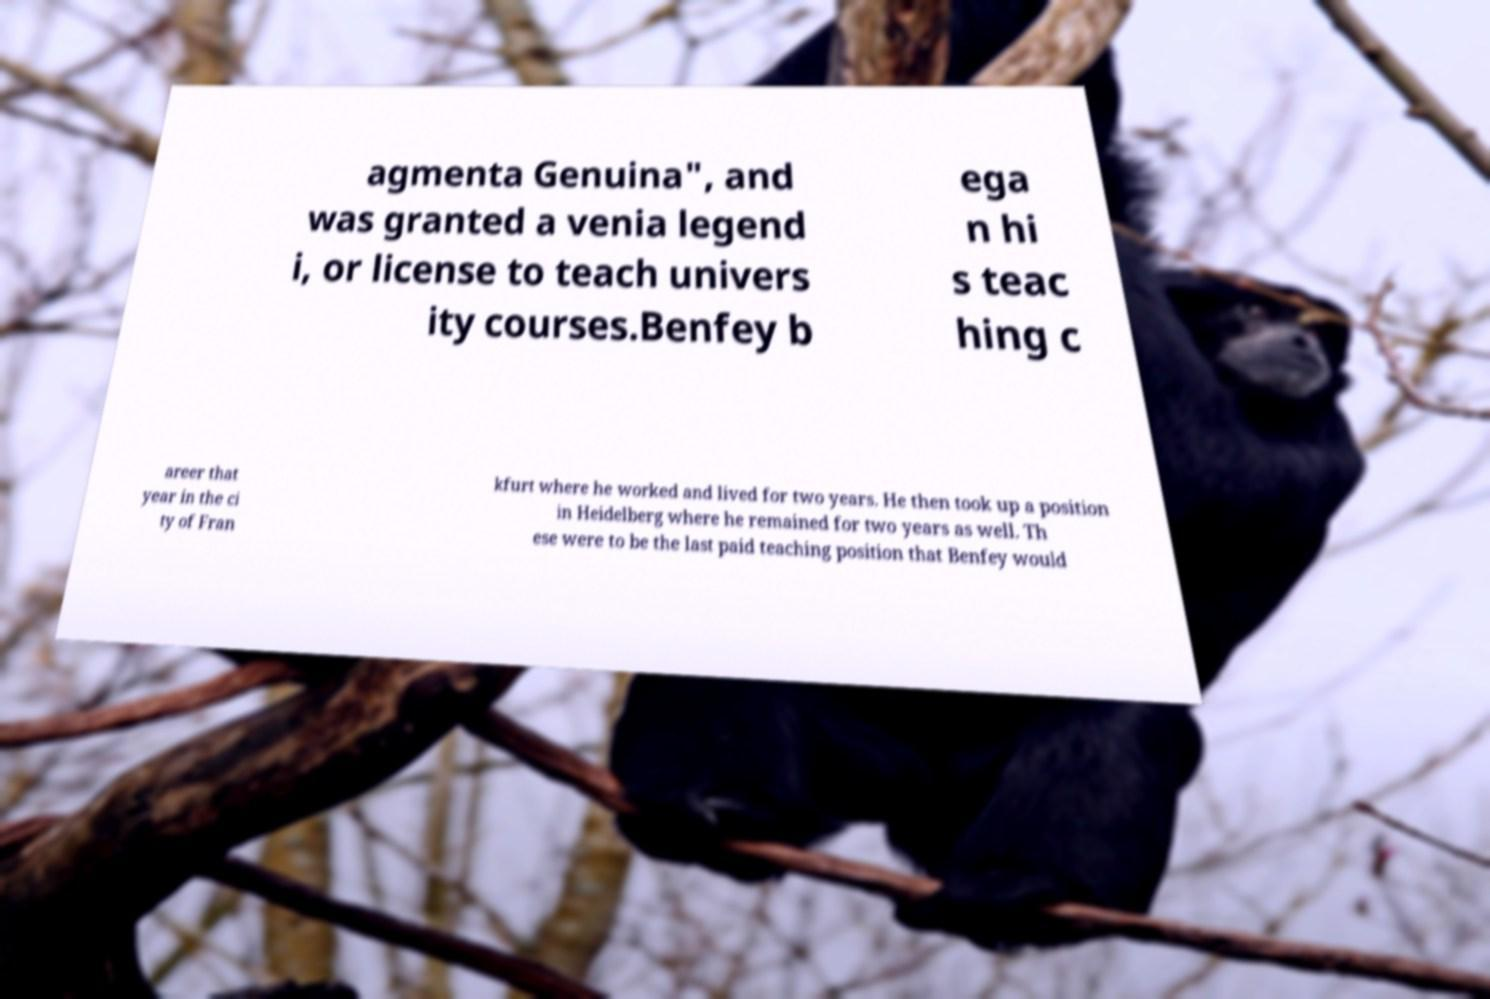For documentation purposes, I need the text within this image transcribed. Could you provide that? agmenta Genuina", and was granted a venia legend i, or license to teach univers ity courses.Benfey b ega n hi s teac hing c areer that year in the ci ty of Fran kfurt where he worked and lived for two years. He then took up a position in Heidelberg where he remained for two years as well. Th ese were to be the last paid teaching position that Benfey would 